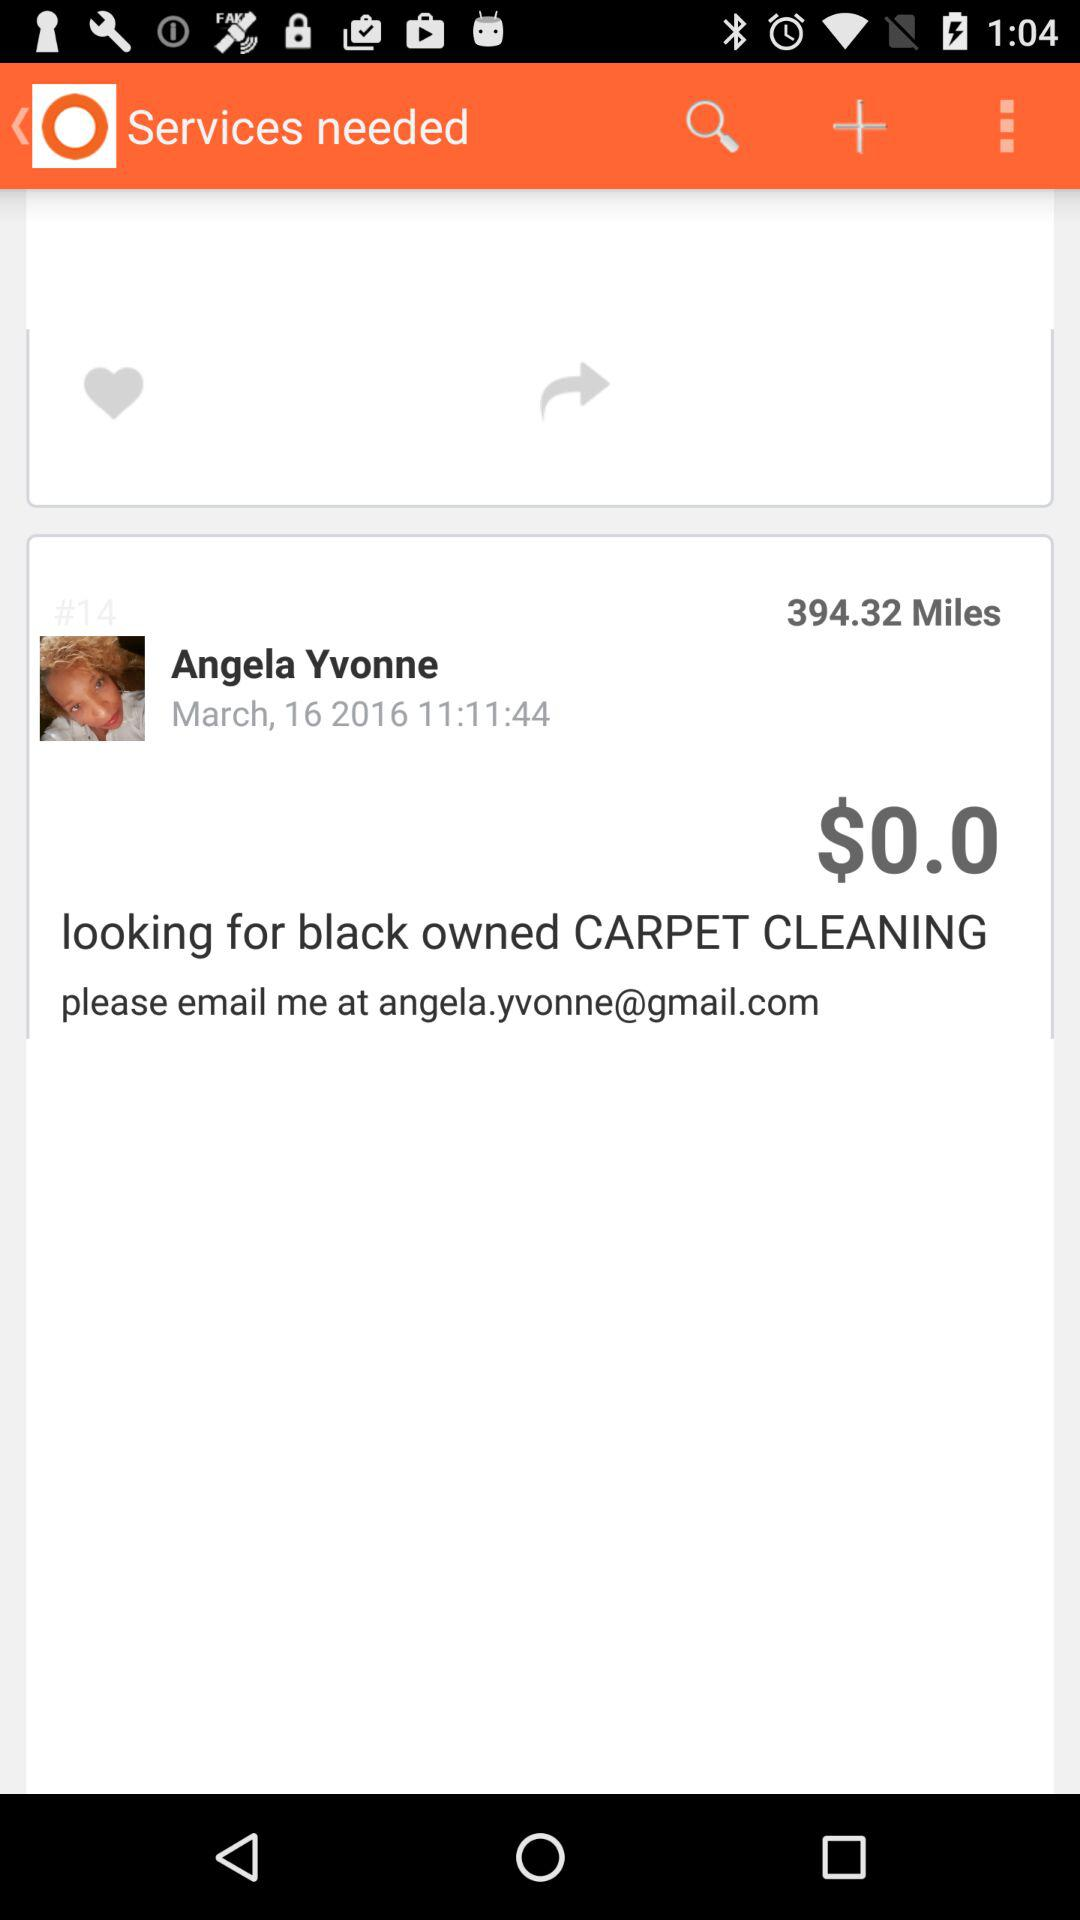What is the email address? The email address is angela.yvonne@gmail.com. 